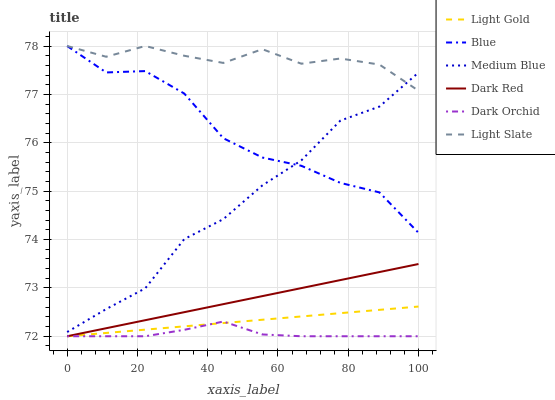Does Dark Red have the minimum area under the curve?
Answer yes or no. No. Does Dark Red have the maximum area under the curve?
Answer yes or no. No. Is Light Slate the smoothest?
Answer yes or no. No. Is Light Slate the roughest?
Answer yes or no. No. Does Light Slate have the lowest value?
Answer yes or no. No. Does Dark Red have the highest value?
Answer yes or no. No. Is Light Gold less than Blue?
Answer yes or no. Yes. Is Light Slate greater than Dark Red?
Answer yes or no. Yes. Does Light Gold intersect Blue?
Answer yes or no. No. 